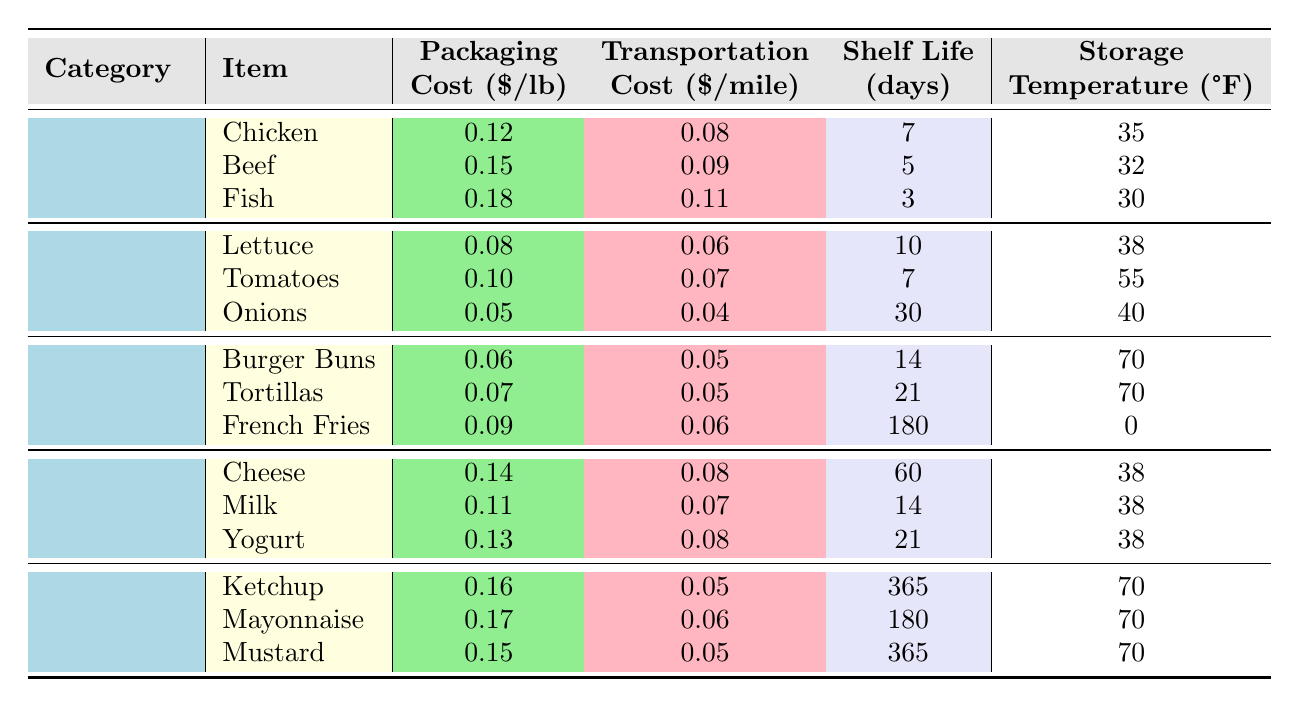What is the packaging cost per pound of chicken? The table shows the packaging cost for chicken under the Proteins category as $0.12 per pound.
Answer: $0.12 What is the shelf life of fish? According to the table, the shelf life of fish is listed as 3 days.
Answer: 3 days Which food has the highest transportation cost per mile? Reviewing the transportation costs in the table, fish has the highest cost at $0.11 per mile.
Answer: Fish What is the average packaging cost of the dairy items listed? The packaging costs for dairy items are $0.14 (Cheese), $0.11 (Milk), and $0.13 (Yogurt). Their sum is $0.38, and dividing by 3 gives an average of $0.38 / 3 = $0.1267, approximately $0.13 per pound.
Answer: $0.13 Do all the condiments have a shelf life of more than 180 days? Checking the shelf life values in the table, ketchup and mustard have a shelf life of 365 days, while mayonnaise is 180 days. Therefore, not all exceed 180 days.
Answer: No Which food category has the longest average shelf life? Calculate the average shelf life for each category: Proteins (5 days), Produce (15 days), Grains (71 days), Dairy (32 days), Condiments (272.5 days). The longest average shelf life is found in the Condiments category.
Answer: Condiments Which has a lower transportation cost per mile, onions or cheese? From the table, onions have a transportation cost of $0.04 per mile, while cheese costs $0.08 per mile. Since $0.04 is less than $0.08, onions have the lower cost.
Answer: Onions How much more does the packaging for Mayonnaise cost compared to Burger Buns? The packaging cost for Mayonnaise is $0.17 and for Burger Buns is $0.06. The difference is $0.17 - $0.06 = $0.11.
Answer: $0.11 Is the storage temperature for French fries lower than that of fish? The table indicates the storage temperature for French fries is 0°F and for fish is 30°F. Therefore, the temperature for French fries is indeed lower.
Answer: Yes What is the total transportation cost per mile for all produce items combined? The transportation costs for the produce items are $0.06 (Lettuce), $0.07 (Tomatoes), and $0.04 (Onions). Adding these gives $0.06 + $0.07 + $0.04 = $0.17 per mile.
Answer: $0.17 